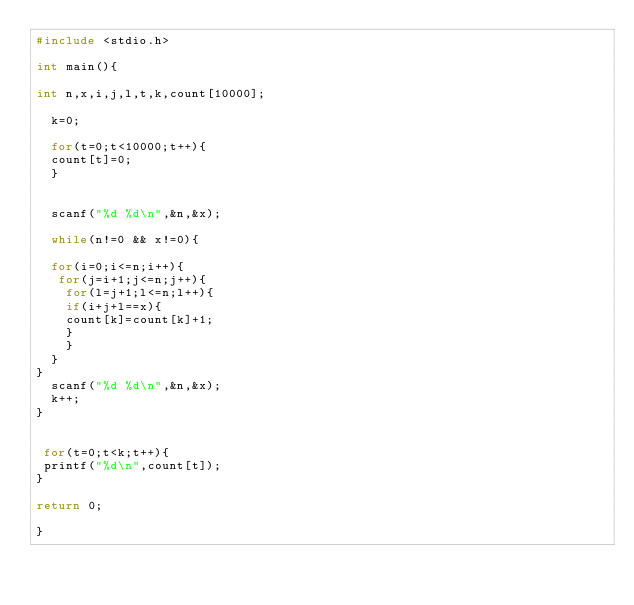<code> <loc_0><loc_0><loc_500><loc_500><_C_>#include <stdio.h>

int main(){

int n,x,i,j,l,t,k,count[10000];

  k=0;

  for(t=0;t<10000;t++){
  count[t]=0;
  }
  
  
  scanf("%d %d\n",&n,&x);

  while(n!=0 && x!=0){

  for(i=0;i<=n;i++){   
   for(j=i+1;j<=n;j++){
    for(l=j+1;l<=n;l++){
    if(i+j+l==x){  
    count[k]=count[k]+1;
    }
    }
  } 
}
  scanf("%d %d\n",&n,&x);
  k++;
}


 for(t=0;t<k;t++){
 printf("%d\n",count[t]);
}

return 0;

}
   

</code> 